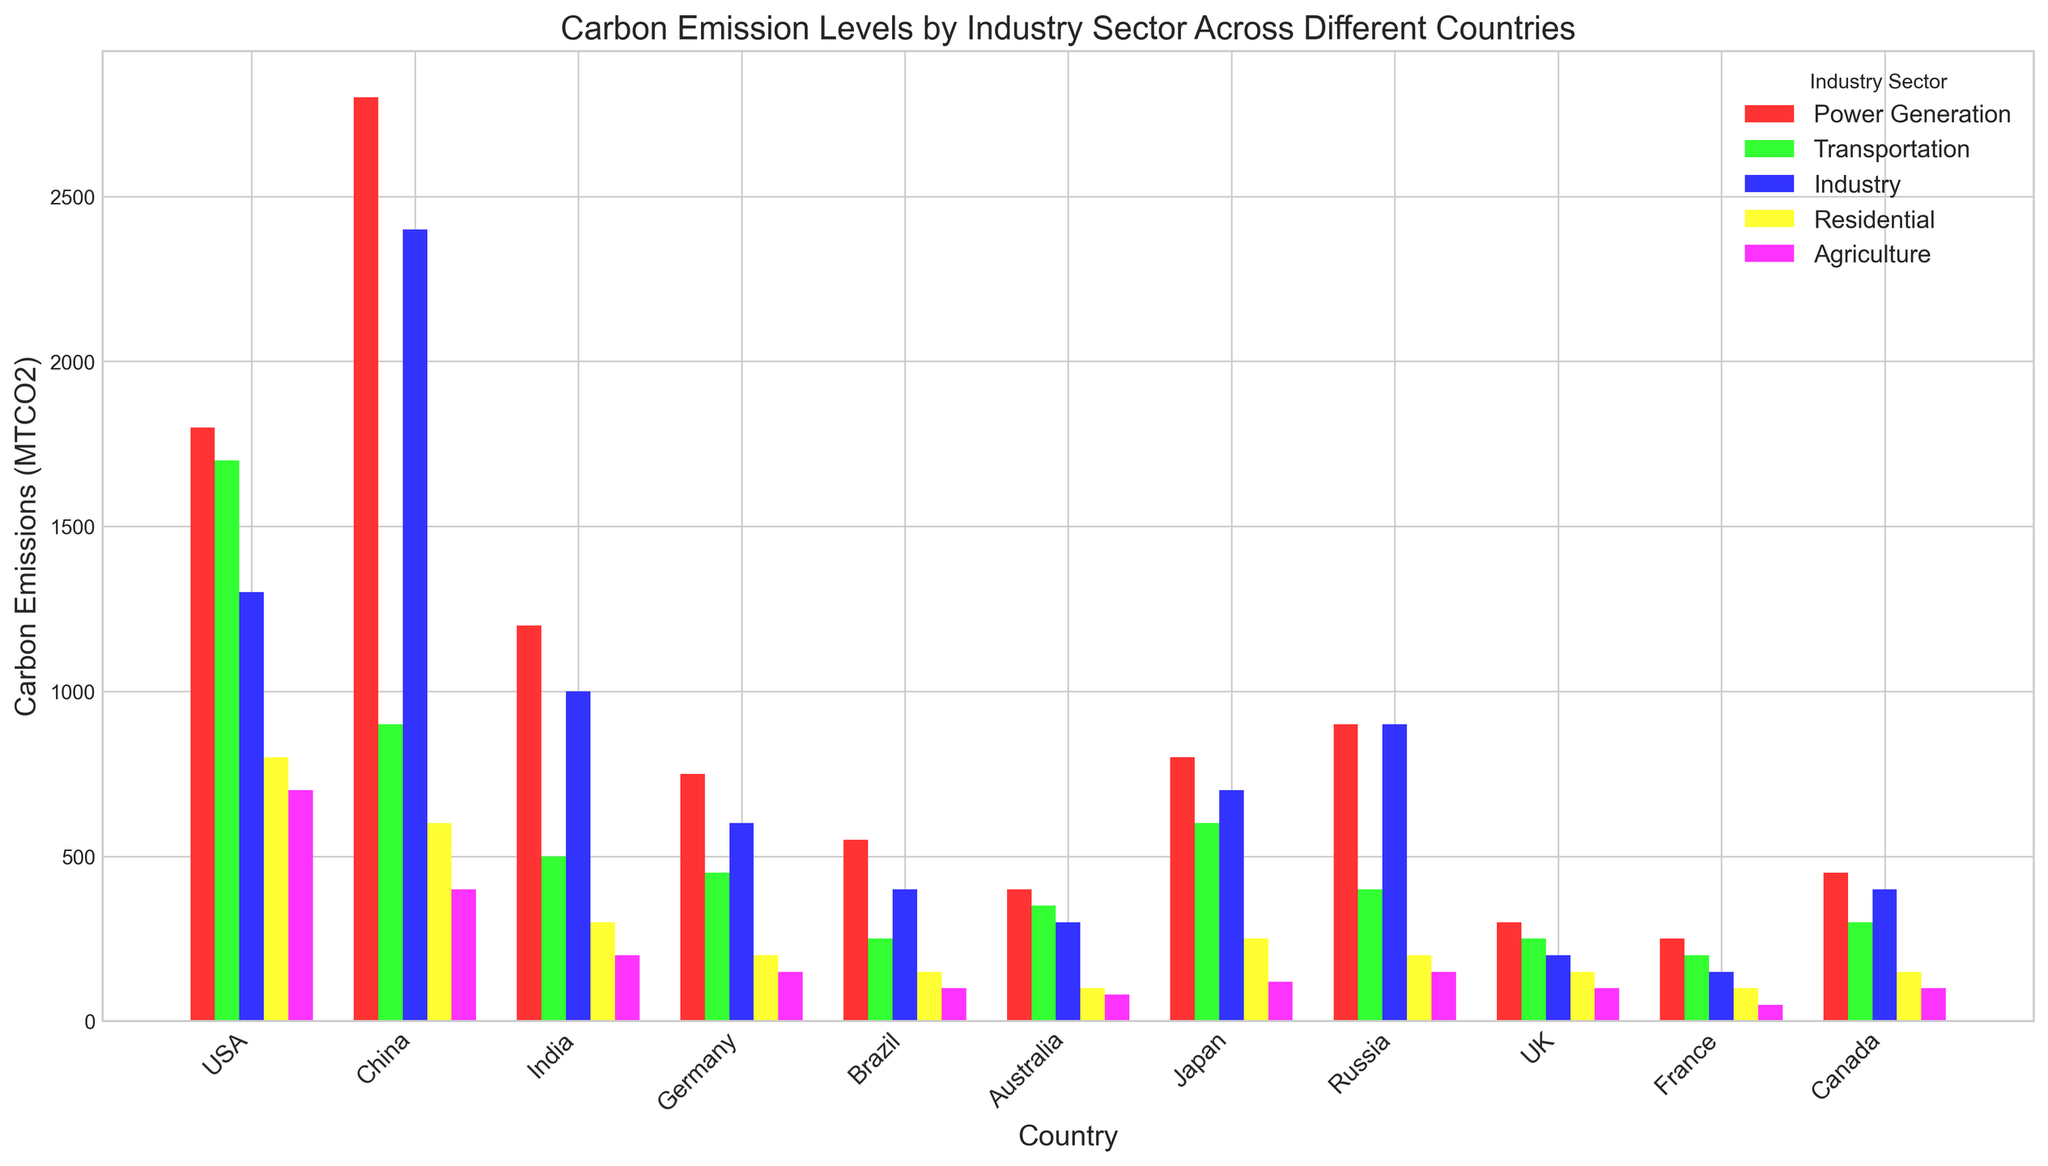Which country has the highest carbon emissions in the Power Generation sector? The Power Generation sector can be identified by the first color in the legend. By comparing the heights of the bars in this sector, China has the highest emissions.
Answer: China Which sector has the lowest carbon emissions in Brazil? Referring to the bars for Brazil and comparing their heights, the Agriculture sector has the lowest emissions.
Answer: Agriculture What is the total carbon emissions for the Transportation sector in the G7 countries (USA, Germany, Japan, UK, France, Canada)? Sum the emissions for the Transportation sector in each G7 country: USA (1700) + Germany (450) + Japan (600) + UK (250) + France (200) + Canada (300). Total = 1700 + 450 + 600 + 250 + 200 + 300 = 3500.
Answer: 3500 MTCO2 Which sector contributes the most to Germany's overall carbon emissions? For Germany, compare the different sector bars and note the highest one, which is Power Generation.
Answer: Power Generation Compare the carbon emissions in the Residential sector between USA and India. Which country has higher emissions? Identify the bars for the Residential sector for USA and India. USA has a taller bar indicating higher emissions compared to India.
Answer: USA What is the total carbon emissions for the Power Generation sector across all listed countries? Sum the emissions for the Power Generation sector in all countries: USA (1800) + China (2800) + India (1200) + Germany (750) + Brazil (550) + Australia (400) + Japan (800) + Russia (900) + UK (300) + France (250) + Canada (450). Total = 9200.
Answer: 9200 MTCO2 Which country has the lowest carbon emissions in the Industry sector? Compare the heights of the Industry sector bars for all countries. UK and France have similarly low emissions, but France is slightly lower.
Answer: France In which country is the difference between the highest and lowest sector emissions the greatest? Calculate the differences for each country: USA (Power Generation 1800 - Agriculture 700 = 1100), China (Power Generation 2800 - Agriculture 400 = 2400), India (Power Generation 1200 - Agriculture 200 = 1000), Germany (Power Generation 750 - Agriculture 150 = 600), Brazil (Power Generation 550 - Agriculture 100 = 450), Australia (Power Generation 400 - Agriculture 80 = 320), Japan (Power Generation 800 - Agriculture 120 = 680), Russia (Power Generation 900 - Agriculture 150 = 750), UK (Power Generation 300 - Agriculture 100 = 200), France (Power Generation 250 - Agriculture 50 = 200), Canada (Power Generation 450 - Agriculture 100 = 350). China has the largest difference.
Answer: China 